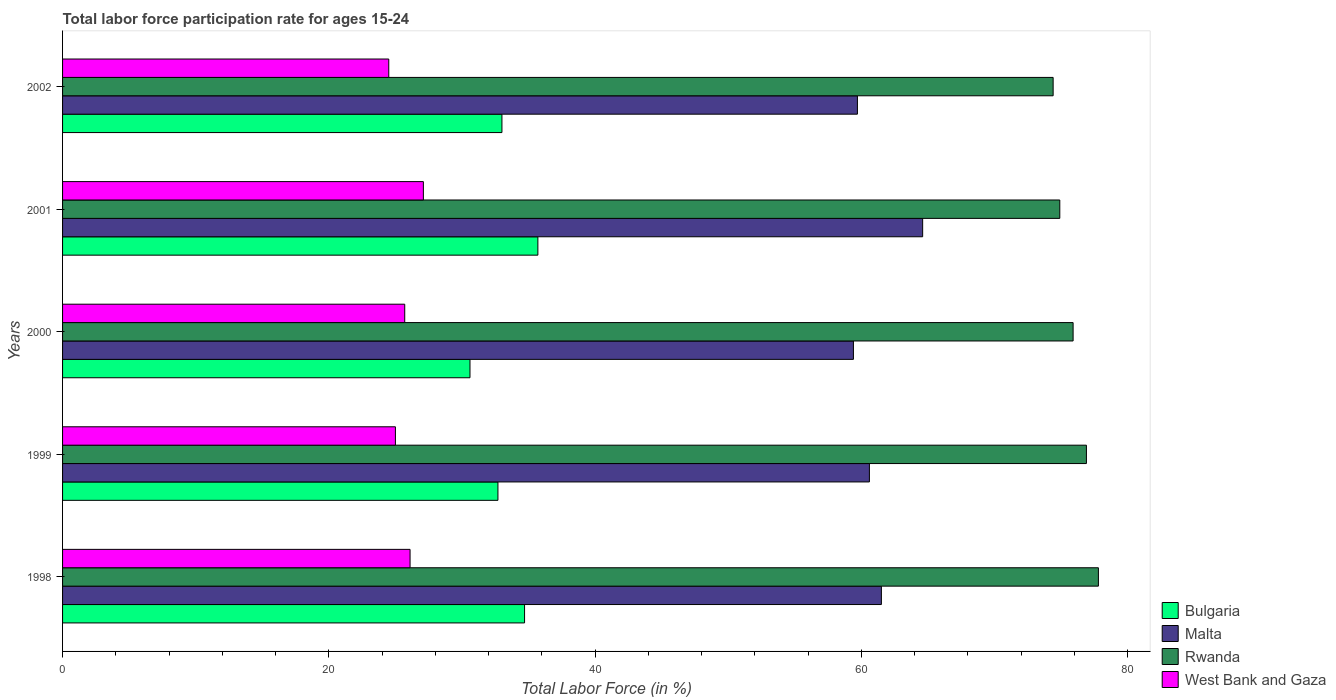How many different coloured bars are there?
Your response must be concise. 4. Are the number of bars per tick equal to the number of legend labels?
Provide a short and direct response. Yes. Are the number of bars on each tick of the Y-axis equal?
Make the answer very short. Yes. How many bars are there on the 5th tick from the top?
Your response must be concise. 4. How many bars are there on the 4th tick from the bottom?
Your answer should be very brief. 4. In how many cases, is the number of bars for a given year not equal to the number of legend labels?
Offer a terse response. 0. Across all years, what is the maximum labor force participation rate in Bulgaria?
Offer a very short reply. 35.7. Across all years, what is the minimum labor force participation rate in Bulgaria?
Provide a succinct answer. 30.6. What is the total labor force participation rate in West Bank and Gaza in the graph?
Give a very brief answer. 128.4. What is the difference between the labor force participation rate in Malta in 1999 and that in 2000?
Your answer should be very brief. 1.2. What is the difference between the labor force participation rate in Malta in 2000 and the labor force participation rate in Rwanda in 2001?
Offer a very short reply. -15.5. What is the average labor force participation rate in Bulgaria per year?
Make the answer very short. 33.34. In the year 1999, what is the difference between the labor force participation rate in Bulgaria and labor force participation rate in West Bank and Gaza?
Provide a succinct answer. 7.7. In how many years, is the labor force participation rate in Bulgaria greater than 12 %?
Ensure brevity in your answer.  5. What is the ratio of the labor force participation rate in West Bank and Gaza in 1998 to that in 2001?
Your response must be concise. 0.96. What is the difference between the highest and the second highest labor force participation rate in Rwanda?
Your answer should be very brief. 0.9. What is the difference between the highest and the lowest labor force participation rate in West Bank and Gaza?
Provide a short and direct response. 2.6. Is the sum of the labor force participation rate in West Bank and Gaza in 1999 and 2002 greater than the maximum labor force participation rate in Malta across all years?
Offer a very short reply. No. Is it the case that in every year, the sum of the labor force participation rate in Rwanda and labor force participation rate in Bulgaria is greater than the sum of labor force participation rate in Malta and labor force participation rate in West Bank and Gaza?
Provide a short and direct response. Yes. What does the 1st bar from the top in 2000 represents?
Your answer should be very brief. West Bank and Gaza. What does the 4th bar from the bottom in 1998 represents?
Give a very brief answer. West Bank and Gaza. Is it the case that in every year, the sum of the labor force participation rate in West Bank and Gaza and labor force participation rate in Malta is greater than the labor force participation rate in Bulgaria?
Keep it short and to the point. Yes. What is the difference between two consecutive major ticks on the X-axis?
Offer a very short reply. 20. Does the graph contain any zero values?
Ensure brevity in your answer.  No. Where does the legend appear in the graph?
Offer a very short reply. Bottom right. How are the legend labels stacked?
Make the answer very short. Vertical. What is the title of the graph?
Make the answer very short. Total labor force participation rate for ages 15-24. Does "Argentina" appear as one of the legend labels in the graph?
Provide a succinct answer. No. What is the label or title of the Y-axis?
Your response must be concise. Years. What is the Total Labor Force (in %) in Bulgaria in 1998?
Provide a succinct answer. 34.7. What is the Total Labor Force (in %) of Malta in 1998?
Make the answer very short. 61.5. What is the Total Labor Force (in %) of Rwanda in 1998?
Your answer should be very brief. 77.8. What is the Total Labor Force (in %) of West Bank and Gaza in 1998?
Your response must be concise. 26.1. What is the Total Labor Force (in %) of Bulgaria in 1999?
Your answer should be compact. 32.7. What is the Total Labor Force (in %) of Malta in 1999?
Give a very brief answer. 60.6. What is the Total Labor Force (in %) of Rwanda in 1999?
Your response must be concise. 76.9. What is the Total Labor Force (in %) of Bulgaria in 2000?
Provide a short and direct response. 30.6. What is the Total Labor Force (in %) of Malta in 2000?
Your answer should be very brief. 59.4. What is the Total Labor Force (in %) in Rwanda in 2000?
Your response must be concise. 75.9. What is the Total Labor Force (in %) of West Bank and Gaza in 2000?
Your response must be concise. 25.7. What is the Total Labor Force (in %) of Bulgaria in 2001?
Your answer should be compact. 35.7. What is the Total Labor Force (in %) of Malta in 2001?
Provide a short and direct response. 64.6. What is the Total Labor Force (in %) of Rwanda in 2001?
Provide a short and direct response. 74.9. What is the Total Labor Force (in %) in West Bank and Gaza in 2001?
Ensure brevity in your answer.  27.1. What is the Total Labor Force (in %) in Bulgaria in 2002?
Your answer should be compact. 33. What is the Total Labor Force (in %) in Malta in 2002?
Keep it short and to the point. 59.7. What is the Total Labor Force (in %) in Rwanda in 2002?
Your answer should be compact. 74.4. What is the Total Labor Force (in %) in West Bank and Gaza in 2002?
Provide a short and direct response. 24.5. Across all years, what is the maximum Total Labor Force (in %) of Bulgaria?
Keep it short and to the point. 35.7. Across all years, what is the maximum Total Labor Force (in %) in Malta?
Offer a terse response. 64.6. Across all years, what is the maximum Total Labor Force (in %) in Rwanda?
Your answer should be compact. 77.8. Across all years, what is the maximum Total Labor Force (in %) of West Bank and Gaza?
Your response must be concise. 27.1. Across all years, what is the minimum Total Labor Force (in %) in Bulgaria?
Keep it short and to the point. 30.6. Across all years, what is the minimum Total Labor Force (in %) in Malta?
Provide a succinct answer. 59.4. Across all years, what is the minimum Total Labor Force (in %) in Rwanda?
Ensure brevity in your answer.  74.4. Across all years, what is the minimum Total Labor Force (in %) of West Bank and Gaza?
Offer a terse response. 24.5. What is the total Total Labor Force (in %) in Bulgaria in the graph?
Keep it short and to the point. 166.7. What is the total Total Labor Force (in %) in Malta in the graph?
Make the answer very short. 305.8. What is the total Total Labor Force (in %) of Rwanda in the graph?
Offer a very short reply. 379.9. What is the total Total Labor Force (in %) in West Bank and Gaza in the graph?
Your answer should be very brief. 128.4. What is the difference between the Total Labor Force (in %) in Bulgaria in 1998 and that in 1999?
Keep it short and to the point. 2. What is the difference between the Total Labor Force (in %) of Malta in 1998 and that in 1999?
Your response must be concise. 0.9. What is the difference between the Total Labor Force (in %) in West Bank and Gaza in 1998 and that in 1999?
Your answer should be compact. 1.1. What is the difference between the Total Labor Force (in %) in Bulgaria in 1998 and that in 2000?
Provide a succinct answer. 4.1. What is the difference between the Total Labor Force (in %) of Rwanda in 1998 and that in 2000?
Your answer should be compact. 1.9. What is the difference between the Total Labor Force (in %) of Bulgaria in 1998 and that in 2001?
Provide a succinct answer. -1. What is the difference between the Total Labor Force (in %) of West Bank and Gaza in 1998 and that in 2001?
Keep it short and to the point. -1. What is the difference between the Total Labor Force (in %) in Rwanda in 1998 and that in 2002?
Your answer should be compact. 3.4. What is the difference between the Total Labor Force (in %) of West Bank and Gaza in 1998 and that in 2002?
Provide a short and direct response. 1.6. What is the difference between the Total Labor Force (in %) of Malta in 1999 and that in 2000?
Make the answer very short. 1.2. What is the difference between the Total Labor Force (in %) in Malta in 1999 and that in 2001?
Make the answer very short. -4. What is the difference between the Total Labor Force (in %) in Malta in 1999 and that in 2002?
Keep it short and to the point. 0.9. What is the difference between the Total Labor Force (in %) in Rwanda in 1999 and that in 2002?
Offer a terse response. 2.5. What is the difference between the Total Labor Force (in %) of Malta in 2000 and that in 2001?
Your answer should be very brief. -5.2. What is the difference between the Total Labor Force (in %) in West Bank and Gaza in 2000 and that in 2001?
Your answer should be very brief. -1.4. What is the difference between the Total Labor Force (in %) in Bulgaria in 2000 and that in 2002?
Provide a short and direct response. -2.4. What is the difference between the Total Labor Force (in %) in Rwanda in 2000 and that in 2002?
Provide a succinct answer. 1.5. What is the difference between the Total Labor Force (in %) of West Bank and Gaza in 2000 and that in 2002?
Provide a succinct answer. 1.2. What is the difference between the Total Labor Force (in %) of Bulgaria in 1998 and the Total Labor Force (in %) of Malta in 1999?
Offer a very short reply. -25.9. What is the difference between the Total Labor Force (in %) in Bulgaria in 1998 and the Total Labor Force (in %) in Rwanda in 1999?
Give a very brief answer. -42.2. What is the difference between the Total Labor Force (in %) in Malta in 1998 and the Total Labor Force (in %) in Rwanda in 1999?
Your response must be concise. -15.4. What is the difference between the Total Labor Force (in %) of Malta in 1998 and the Total Labor Force (in %) of West Bank and Gaza in 1999?
Give a very brief answer. 36.5. What is the difference between the Total Labor Force (in %) of Rwanda in 1998 and the Total Labor Force (in %) of West Bank and Gaza in 1999?
Provide a short and direct response. 52.8. What is the difference between the Total Labor Force (in %) of Bulgaria in 1998 and the Total Labor Force (in %) of Malta in 2000?
Make the answer very short. -24.7. What is the difference between the Total Labor Force (in %) in Bulgaria in 1998 and the Total Labor Force (in %) in Rwanda in 2000?
Your answer should be very brief. -41.2. What is the difference between the Total Labor Force (in %) in Bulgaria in 1998 and the Total Labor Force (in %) in West Bank and Gaza in 2000?
Offer a terse response. 9. What is the difference between the Total Labor Force (in %) in Malta in 1998 and the Total Labor Force (in %) in Rwanda in 2000?
Your answer should be very brief. -14.4. What is the difference between the Total Labor Force (in %) of Malta in 1998 and the Total Labor Force (in %) of West Bank and Gaza in 2000?
Provide a short and direct response. 35.8. What is the difference between the Total Labor Force (in %) of Rwanda in 1998 and the Total Labor Force (in %) of West Bank and Gaza in 2000?
Give a very brief answer. 52.1. What is the difference between the Total Labor Force (in %) of Bulgaria in 1998 and the Total Labor Force (in %) of Malta in 2001?
Give a very brief answer. -29.9. What is the difference between the Total Labor Force (in %) of Bulgaria in 1998 and the Total Labor Force (in %) of Rwanda in 2001?
Your answer should be very brief. -40.2. What is the difference between the Total Labor Force (in %) of Malta in 1998 and the Total Labor Force (in %) of West Bank and Gaza in 2001?
Provide a succinct answer. 34.4. What is the difference between the Total Labor Force (in %) of Rwanda in 1998 and the Total Labor Force (in %) of West Bank and Gaza in 2001?
Provide a short and direct response. 50.7. What is the difference between the Total Labor Force (in %) of Bulgaria in 1998 and the Total Labor Force (in %) of Rwanda in 2002?
Offer a very short reply. -39.7. What is the difference between the Total Labor Force (in %) in Malta in 1998 and the Total Labor Force (in %) in Rwanda in 2002?
Offer a very short reply. -12.9. What is the difference between the Total Labor Force (in %) of Malta in 1998 and the Total Labor Force (in %) of West Bank and Gaza in 2002?
Provide a succinct answer. 37. What is the difference between the Total Labor Force (in %) of Rwanda in 1998 and the Total Labor Force (in %) of West Bank and Gaza in 2002?
Your answer should be very brief. 53.3. What is the difference between the Total Labor Force (in %) in Bulgaria in 1999 and the Total Labor Force (in %) in Malta in 2000?
Offer a very short reply. -26.7. What is the difference between the Total Labor Force (in %) in Bulgaria in 1999 and the Total Labor Force (in %) in Rwanda in 2000?
Give a very brief answer. -43.2. What is the difference between the Total Labor Force (in %) of Bulgaria in 1999 and the Total Labor Force (in %) of West Bank and Gaza in 2000?
Give a very brief answer. 7. What is the difference between the Total Labor Force (in %) of Malta in 1999 and the Total Labor Force (in %) of Rwanda in 2000?
Offer a terse response. -15.3. What is the difference between the Total Labor Force (in %) in Malta in 1999 and the Total Labor Force (in %) in West Bank and Gaza in 2000?
Keep it short and to the point. 34.9. What is the difference between the Total Labor Force (in %) in Rwanda in 1999 and the Total Labor Force (in %) in West Bank and Gaza in 2000?
Your answer should be very brief. 51.2. What is the difference between the Total Labor Force (in %) in Bulgaria in 1999 and the Total Labor Force (in %) in Malta in 2001?
Ensure brevity in your answer.  -31.9. What is the difference between the Total Labor Force (in %) of Bulgaria in 1999 and the Total Labor Force (in %) of Rwanda in 2001?
Give a very brief answer. -42.2. What is the difference between the Total Labor Force (in %) of Bulgaria in 1999 and the Total Labor Force (in %) of West Bank and Gaza in 2001?
Your answer should be compact. 5.6. What is the difference between the Total Labor Force (in %) in Malta in 1999 and the Total Labor Force (in %) in Rwanda in 2001?
Provide a short and direct response. -14.3. What is the difference between the Total Labor Force (in %) of Malta in 1999 and the Total Labor Force (in %) of West Bank and Gaza in 2001?
Your answer should be very brief. 33.5. What is the difference between the Total Labor Force (in %) of Rwanda in 1999 and the Total Labor Force (in %) of West Bank and Gaza in 2001?
Give a very brief answer. 49.8. What is the difference between the Total Labor Force (in %) of Bulgaria in 1999 and the Total Labor Force (in %) of Malta in 2002?
Keep it short and to the point. -27. What is the difference between the Total Labor Force (in %) in Bulgaria in 1999 and the Total Labor Force (in %) in Rwanda in 2002?
Offer a very short reply. -41.7. What is the difference between the Total Labor Force (in %) of Malta in 1999 and the Total Labor Force (in %) of Rwanda in 2002?
Provide a succinct answer. -13.8. What is the difference between the Total Labor Force (in %) of Malta in 1999 and the Total Labor Force (in %) of West Bank and Gaza in 2002?
Ensure brevity in your answer.  36.1. What is the difference between the Total Labor Force (in %) in Rwanda in 1999 and the Total Labor Force (in %) in West Bank and Gaza in 2002?
Ensure brevity in your answer.  52.4. What is the difference between the Total Labor Force (in %) in Bulgaria in 2000 and the Total Labor Force (in %) in Malta in 2001?
Your answer should be compact. -34. What is the difference between the Total Labor Force (in %) of Bulgaria in 2000 and the Total Labor Force (in %) of Rwanda in 2001?
Provide a short and direct response. -44.3. What is the difference between the Total Labor Force (in %) of Malta in 2000 and the Total Labor Force (in %) of Rwanda in 2001?
Provide a short and direct response. -15.5. What is the difference between the Total Labor Force (in %) in Malta in 2000 and the Total Labor Force (in %) in West Bank and Gaza in 2001?
Keep it short and to the point. 32.3. What is the difference between the Total Labor Force (in %) of Rwanda in 2000 and the Total Labor Force (in %) of West Bank and Gaza in 2001?
Offer a terse response. 48.8. What is the difference between the Total Labor Force (in %) of Bulgaria in 2000 and the Total Labor Force (in %) of Malta in 2002?
Offer a terse response. -29.1. What is the difference between the Total Labor Force (in %) of Bulgaria in 2000 and the Total Labor Force (in %) of Rwanda in 2002?
Your answer should be very brief. -43.8. What is the difference between the Total Labor Force (in %) of Malta in 2000 and the Total Labor Force (in %) of West Bank and Gaza in 2002?
Your answer should be very brief. 34.9. What is the difference between the Total Labor Force (in %) in Rwanda in 2000 and the Total Labor Force (in %) in West Bank and Gaza in 2002?
Give a very brief answer. 51.4. What is the difference between the Total Labor Force (in %) of Bulgaria in 2001 and the Total Labor Force (in %) of Malta in 2002?
Keep it short and to the point. -24. What is the difference between the Total Labor Force (in %) in Bulgaria in 2001 and the Total Labor Force (in %) in Rwanda in 2002?
Offer a terse response. -38.7. What is the difference between the Total Labor Force (in %) in Bulgaria in 2001 and the Total Labor Force (in %) in West Bank and Gaza in 2002?
Give a very brief answer. 11.2. What is the difference between the Total Labor Force (in %) of Malta in 2001 and the Total Labor Force (in %) of West Bank and Gaza in 2002?
Offer a very short reply. 40.1. What is the difference between the Total Labor Force (in %) of Rwanda in 2001 and the Total Labor Force (in %) of West Bank and Gaza in 2002?
Provide a short and direct response. 50.4. What is the average Total Labor Force (in %) of Bulgaria per year?
Your answer should be compact. 33.34. What is the average Total Labor Force (in %) in Malta per year?
Ensure brevity in your answer.  61.16. What is the average Total Labor Force (in %) of Rwanda per year?
Offer a very short reply. 75.98. What is the average Total Labor Force (in %) of West Bank and Gaza per year?
Provide a succinct answer. 25.68. In the year 1998, what is the difference between the Total Labor Force (in %) in Bulgaria and Total Labor Force (in %) in Malta?
Offer a very short reply. -26.8. In the year 1998, what is the difference between the Total Labor Force (in %) of Bulgaria and Total Labor Force (in %) of Rwanda?
Make the answer very short. -43.1. In the year 1998, what is the difference between the Total Labor Force (in %) in Malta and Total Labor Force (in %) in Rwanda?
Give a very brief answer. -16.3. In the year 1998, what is the difference between the Total Labor Force (in %) in Malta and Total Labor Force (in %) in West Bank and Gaza?
Your answer should be very brief. 35.4. In the year 1998, what is the difference between the Total Labor Force (in %) of Rwanda and Total Labor Force (in %) of West Bank and Gaza?
Your answer should be very brief. 51.7. In the year 1999, what is the difference between the Total Labor Force (in %) in Bulgaria and Total Labor Force (in %) in Malta?
Offer a terse response. -27.9. In the year 1999, what is the difference between the Total Labor Force (in %) in Bulgaria and Total Labor Force (in %) in Rwanda?
Provide a short and direct response. -44.2. In the year 1999, what is the difference between the Total Labor Force (in %) of Malta and Total Labor Force (in %) of Rwanda?
Make the answer very short. -16.3. In the year 1999, what is the difference between the Total Labor Force (in %) in Malta and Total Labor Force (in %) in West Bank and Gaza?
Ensure brevity in your answer.  35.6. In the year 1999, what is the difference between the Total Labor Force (in %) of Rwanda and Total Labor Force (in %) of West Bank and Gaza?
Provide a succinct answer. 51.9. In the year 2000, what is the difference between the Total Labor Force (in %) in Bulgaria and Total Labor Force (in %) in Malta?
Give a very brief answer. -28.8. In the year 2000, what is the difference between the Total Labor Force (in %) in Bulgaria and Total Labor Force (in %) in Rwanda?
Your answer should be very brief. -45.3. In the year 2000, what is the difference between the Total Labor Force (in %) in Malta and Total Labor Force (in %) in Rwanda?
Ensure brevity in your answer.  -16.5. In the year 2000, what is the difference between the Total Labor Force (in %) in Malta and Total Labor Force (in %) in West Bank and Gaza?
Your response must be concise. 33.7. In the year 2000, what is the difference between the Total Labor Force (in %) in Rwanda and Total Labor Force (in %) in West Bank and Gaza?
Provide a short and direct response. 50.2. In the year 2001, what is the difference between the Total Labor Force (in %) in Bulgaria and Total Labor Force (in %) in Malta?
Your answer should be very brief. -28.9. In the year 2001, what is the difference between the Total Labor Force (in %) of Bulgaria and Total Labor Force (in %) of Rwanda?
Provide a short and direct response. -39.2. In the year 2001, what is the difference between the Total Labor Force (in %) of Bulgaria and Total Labor Force (in %) of West Bank and Gaza?
Ensure brevity in your answer.  8.6. In the year 2001, what is the difference between the Total Labor Force (in %) in Malta and Total Labor Force (in %) in Rwanda?
Keep it short and to the point. -10.3. In the year 2001, what is the difference between the Total Labor Force (in %) in Malta and Total Labor Force (in %) in West Bank and Gaza?
Provide a short and direct response. 37.5. In the year 2001, what is the difference between the Total Labor Force (in %) in Rwanda and Total Labor Force (in %) in West Bank and Gaza?
Your answer should be compact. 47.8. In the year 2002, what is the difference between the Total Labor Force (in %) in Bulgaria and Total Labor Force (in %) in Malta?
Provide a succinct answer. -26.7. In the year 2002, what is the difference between the Total Labor Force (in %) of Bulgaria and Total Labor Force (in %) of Rwanda?
Make the answer very short. -41.4. In the year 2002, what is the difference between the Total Labor Force (in %) of Bulgaria and Total Labor Force (in %) of West Bank and Gaza?
Your response must be concise. 8.5. In the year 2002, what is the difference between the Total Labor Force (in %) of Malta and Total Labor Force (in %) of Rwanda?
Make the answer very short. -14.7. In the year 2002, what is the difference between the Total Labor Force (in %) of Malta and Total Labor Force (in %) of West Bank and Gaza?
Your answer should be very brief. 35.2. In the year 2002, what is the difference between the Total Labor Force (in %) of Rwanda and Total Labor Force (in %) of West Bank and Gaza?
Make the answer very short. 49.9. What is the ratio of the Total Labor Force (in %) of Bulgaria in 1998 to that in 1999?
Provide a short and direct response. 1.06. What is the ratio of the Total Labor Force (in %) of Malta in 1998 to that in 1999?
Offer a very short reply. 1.01. What is the ratio of the Total Labor Force (in %) in Rwanda in 1998 to that in 1999?
Your answer should be very brief. 1.01. What is the ratio of the Total Labor Force (in %) of West Bank and Gaza in 1998 to that in 1999?
Your answer should be very brief. 1.04. What is the ratio of the Total Labor Force (in %) of Bulgaria in 1998 to that in 2000?
Give a very brief answer. 1.13. What is the ratio of the Total Labor Force (in %) in Malta in 1998 to that in 2000?
Ensure brevity in your answer.  1.04. What is the ratio of the Total Labor Force (in %) of West Bank and Gaza in 1998 to that in 2000?
Offer a very short reply. 1.02. What is the ratio of the Total Labor Force (in %) of Malta in 1998 to that in 2001?
Provide a short and direct response. 0.95. What is the ratio of the Total Labor Force (in %) of Rwanda in 1998 to that in 2001?
Your answer should be very brief. 1.04. What is the ratio of the Total Labor Force (in %) of West Bank and Gaza in 1998 to that in 2001?
Offer a terse response. 0.96. What is the ratio of the Total Labor Force (in %) of Bulgaria in 1998 to that in 2002?
Give a very brief answer. 1.05. What is the ratio of the Total Labor Force (in %) of Malta in 1998 to that in 2002?
Offer a terse response. 1.03. What is the ratio of the Total Labor Force (in %) of Rwanda in 1998 to that in 2002?
Your answer should be very brief. 1.05. What is the ratio of the Total Labor Force (in %) in West Bank and Gaza in 1998 to that in 2002?
Provide a short and direct response. 1.07. What is the ratio of the Total Labor Force (in %) of Bulgaria in 1999 to that in 2000?
Offer a terse response. 1.07. What is the ratio of the Total Labor Force (in %) in Malta in 1999 to that in 2000?
Keep it short and to the point. 1.02. What is the ratio of the Total Labor Force (in %) in Rwanda in 1999 to that in 2000?
Give a very brief answer. 1.01. What is the ratio of the Total Labor Force (in %) in West Bank and Gaza in 1999 to that in 2000?
Provide a succinct answer. 0.97. What is the ratio of the Total Labor Force (in %) of Bulgaria in 1999 to that in 2001?
Provide a short and direct response. 0.92. What is the ratio of the Total Labor Force (in %) of Malta in 1999 to that in 2001?
Ensure brevity in your answer.  0.94. What is the ratio of the Total Labor Force (in %) in Rwanda in 1999 to that in 2001?
Offer a very short reply. 1.03. What is the ratio of the Total Labor Force (in %) of West Bank and Gaza in 1999 to that in 2001?
Ensure brevity in your answer.  0.92. What is the ratio of the Total Labor Force (in %) in Bulgaria in 1999 to that in 2002?
Provide a succinct answer. 0.99. What is the ratio of the Total Labor Force (in %) of Malta in 1999 to that in 2002?
Offer a very short reply. 1.02. What is the ratio of the Total Labor Force (in %) in Rwanda in 1999 to that in 2002?
Provide a succinct answer. 1.03. What is the ratio of the Total Labor Force (in %) of West Bank and Gaza in 1999 to that in 2002?
Offer a very short reply. 1.02. What is the ratio of the Total Labor Force (in %) in Bulgaria in 2000 to that in 2001?
Offer a very short reply. 0.86. What is the ratio of the Total Labor Force (in %) of Malta in 2000 to that in 2001?
Make the answer very short. 0.92. What is the ratio of the Total Labor Force (in %) of Rwanda in 2000 to that in 2001?
Ensure brevity in your answer.  1.01. What is the ratio of the Total Labor Force (in %) of West Bank and Gaza in 2000 to that in 2001?
Provide a succinct answer. 0.95. What is the ratio of the Total Labor Force (in %) of Bulgaria in 2000 to that in 2002?
Provide a short and direct response. 0.93. What is the ratio of the Total Labor Force (in %) of Rwanda in 2000 to that in 2002?
Keep it short and to the point. 1.02. What is the ratio of the Total Labor Force (in %) in West Bank and Gaza in 2000 to that in 2002?
Give a very brief answer. 1.05. What is the ratio of the Total Labor Force (in %) in Bulgaria in 2001 to that in 2002?
Your answer should be very brief. 1.08. What is the ratio of the Total Labor Force (in %) of Malta in 2001 to that in 2002?
Your answer should be very brief. 1.08. What is the ratio of the Total Labor Force (in %) in Rwanda in 2001 to that in 2002?
Provide a short and direct response. 1.01. What is the ratio of the Total Labor Force (in %) of West Bank and Gaza in 2001 to that in 2002?
Make the answer very short. 1.11. What is the difference between the highest and the second highest Total Labor Force (in %) in Bulgaria?
Give a very brief answer. 1. What is the difference between the highest and the second highest Total Labor Force (in %) of Rwanda?
Your response must be concise. 0.9. What is the difference between the highest and the lowest Total Labor Force (in %) in Bulgaria?
Ensure brevity in your answer.  5.1. What is the difference between the highest and the lowest Total Labor Force (in %) of Rwanda?
Give a very brief answer. 3.4. 